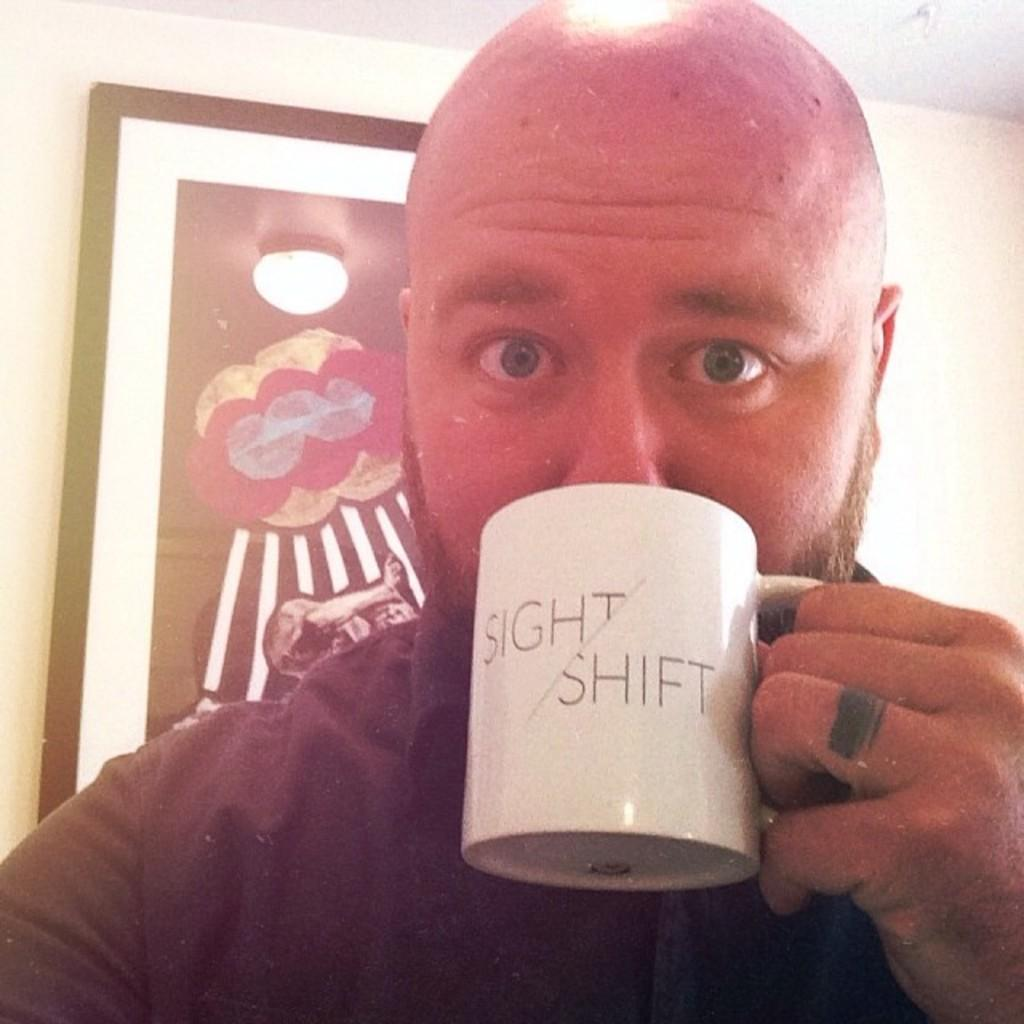Provide a one-sentence caption for the provided image. A bald bearded man drinking from a white coffee mug labeled 'Sight/Shift'. 